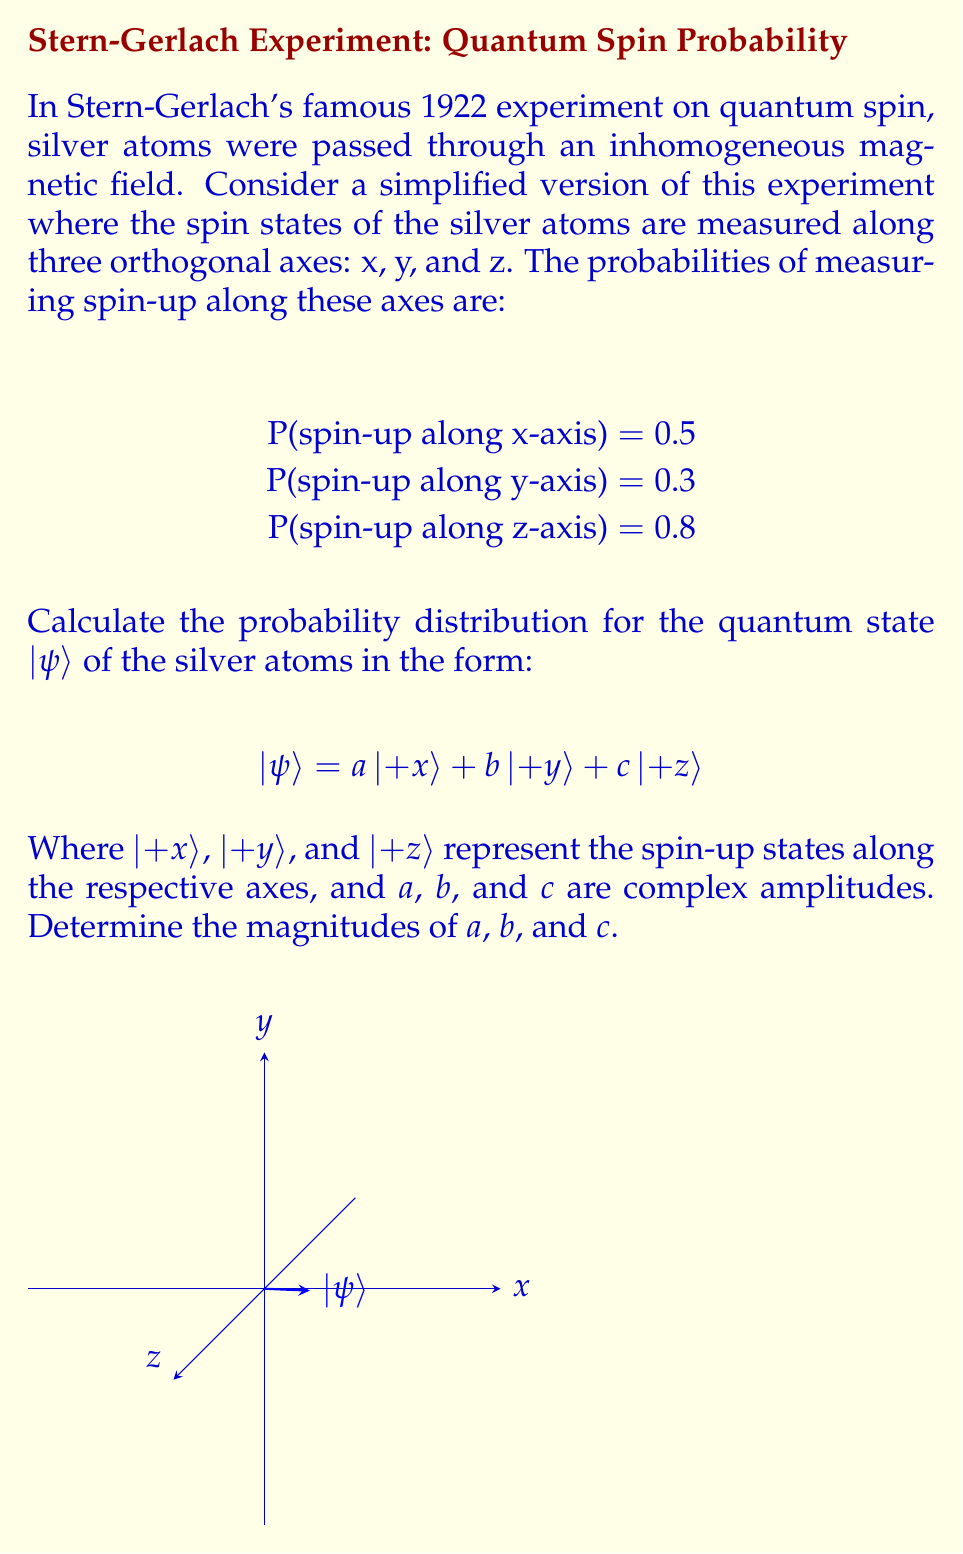Help me with this question. To solve this problem, we'll follow these steps:

1) In quantum mechanics, the probability of measuring a particular state is given by the square of the magnitude of its amplitude in the wavefunction. For a normalized wavefunction:

   $P(+x) = |a|^2 = 0.5$
   $P(+y) = |b|^2 = 0.3$
   $P(+z) = |c|^2 = 0.8$

2) To find the magnitudes of $a$, $b$, and $c$, we simply take the square root of these probabilities:

   $|a| = \sqrt{0.5} \approx 0.7071$
   $|b| = \sqrt{0.3} \approx 0.5477$
   $|c| = \sqrt{0.8} \approx 0.8944$

3) However, we need to check if this state is properly normalized. In quantum mechanics, the sum of the squares of the amplitudes should equal 1:

   $|a|^2 + |b|^2 + |c|^2 = 0.5 + 0.3 + 0.8 = 1.6$

4) This sum is greater than 1, indicating that these probabilities cannot represent a valid quantum state in this form. This discrepancy likely arises from the simplification of the Stern-Gerlach experiment in our problem setup.

5) To create a valid quantum state, we need to normalize the amplitudes. We can do this by dividing each amplitude by the square root of the sum of their squares:

   $\text{Normalization factor} = \sqrt{0.5 + 0.3 + 0.8} = \sqrt{1.6} = 1.2649$

6) The normalized amplitudes are:

   $|a| = \frac{\sqrt{0.5}}{1.2649} \approx 0.5590$
   $|b| = \frac{\sqrt{0.3}}{1.2649} \approx 0.4330$
   $|c| = \frac{\sqrt{0.8}}{1.2649} \approx 0.7071$

These normalized amplitudes represent the probability distribution of the quantum state that best fits the given probabilities while maintaining proper normalization.
Answer: $|a| \approx 0.5590$, $|b| \approx 0.4330$, $|c| \approx 0.7071$ 